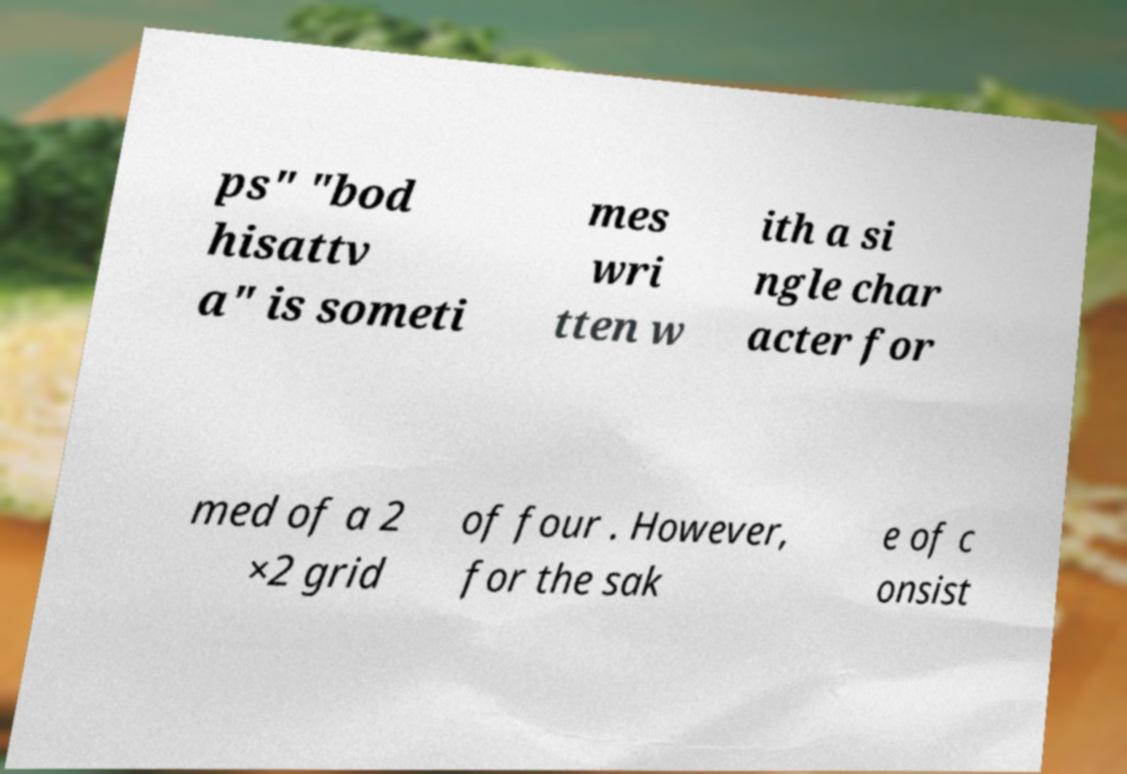Could you assist in decoding the text presented in this image and type it out clearly? ps" "bod hisattv a" is someti mes wri tten w ith a si ngle char acter for med of a 2 ×2 grid of four . However, for the sak e of c onsist 